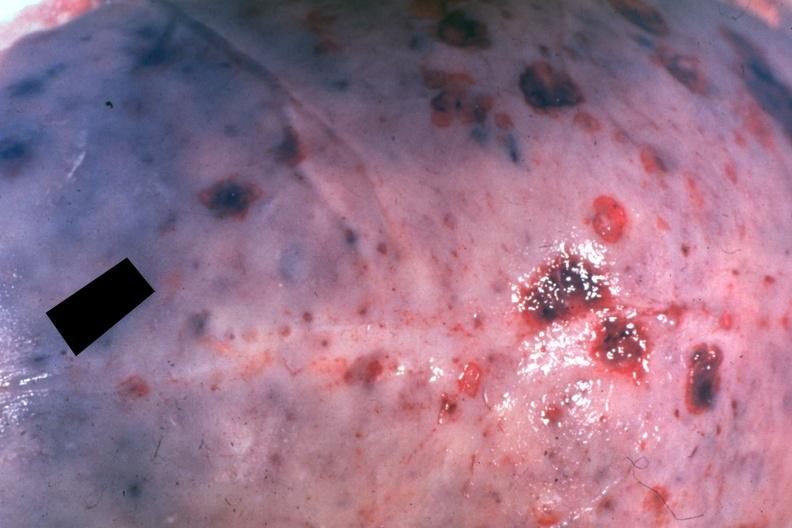s lymphoma present?
Answer the question using a single word or phrase. Yes 